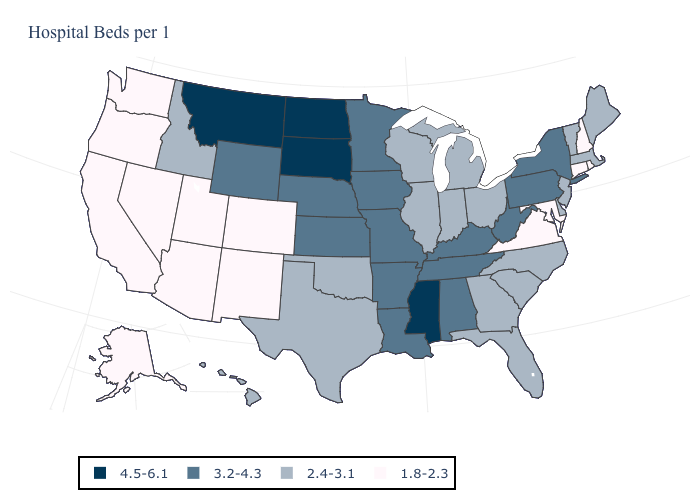What is the value of Rhode Island?
Answer briefly. 1.8-2.3. Does the first symbol in the legend represent the smallest category?
Give a very brief answer. No. What is the value of Kansas?
Be succinct. 3.2-4.3. Name the states that have a value in the range 4.5-6.1?
Short answer required. Mississippi, Montana, North Dakota, South Dakota. Does Maryland have the lowest value in the South?
Keep it brief. Yes. Does South Dakota have the highest value in the MidWest?
Be succinct. Yes. Which states hav the highest value in the South?
Give a very brief answer. Mississippi. What is the value of Washington?
Answer briefly. 1.8-2.3. Name the states that have a value in the range 4.5-6.1?
Answer briefly. Mississippi, Montana, North Dakota, South Dakota. What is the value of Indiana?
Give a very brief answer. 2.4-3.1. Does Delaware have the same value as Missouri?
Be succinct. No. Name the states that have a value in the range 1.8-2.3?
Answer briefly. Alaska, Arizona, California, Colorado, Connecticut, Maryland, Nevada, New Hampshire, New Mexico, Oregon, Rhode Island, Utah, Virginia, Washington. Name the states that have a value in the range 4.5-6.1?
Concise answer only. Mississippi, Montana, North Dakota, South Dakota. What is the value of North Carolina?
Be succinct. 2.4-3.1. Which states have the lowest value in the South?
Be succinct. Maryland, Virginia. 